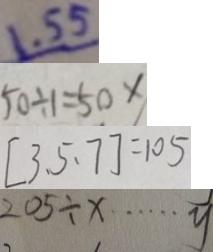Convert formula to latex. <formula><loc_0><loc_0><loc_500><loc_500>1 . 5 5 
 5 0 \div 1 = 5 0 \times 
 [ 3 、 5 、 7 ] = 1 0 5 
 2 0 5 \div x \cdots y</formula> 